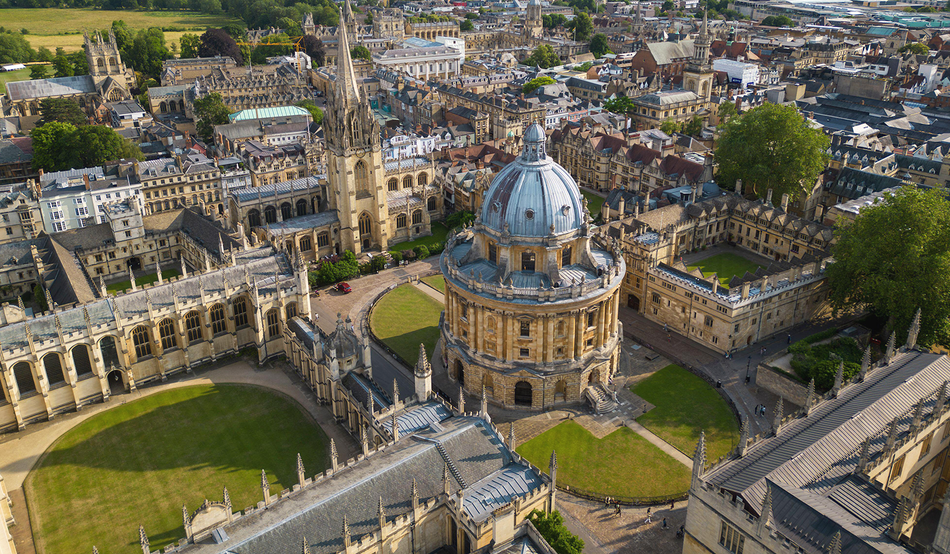Could you describe the main building in the image and its significance? The main building featured prominently in the image is the Radcliffe Camera, an iconic library of Oxford University. Designed by James Gibbs and completed in 1749, the Radcliffe Camera is an outstanding example of English Palladian architecture. Its distinctive circular shape and grand dome are significant landmarks in Oxford. Originally built to house the Radcliffe Science Library, it now serves as a reading room for the Bodleian Library, symbolizing the university's rich tradition of scholarship and learning. 